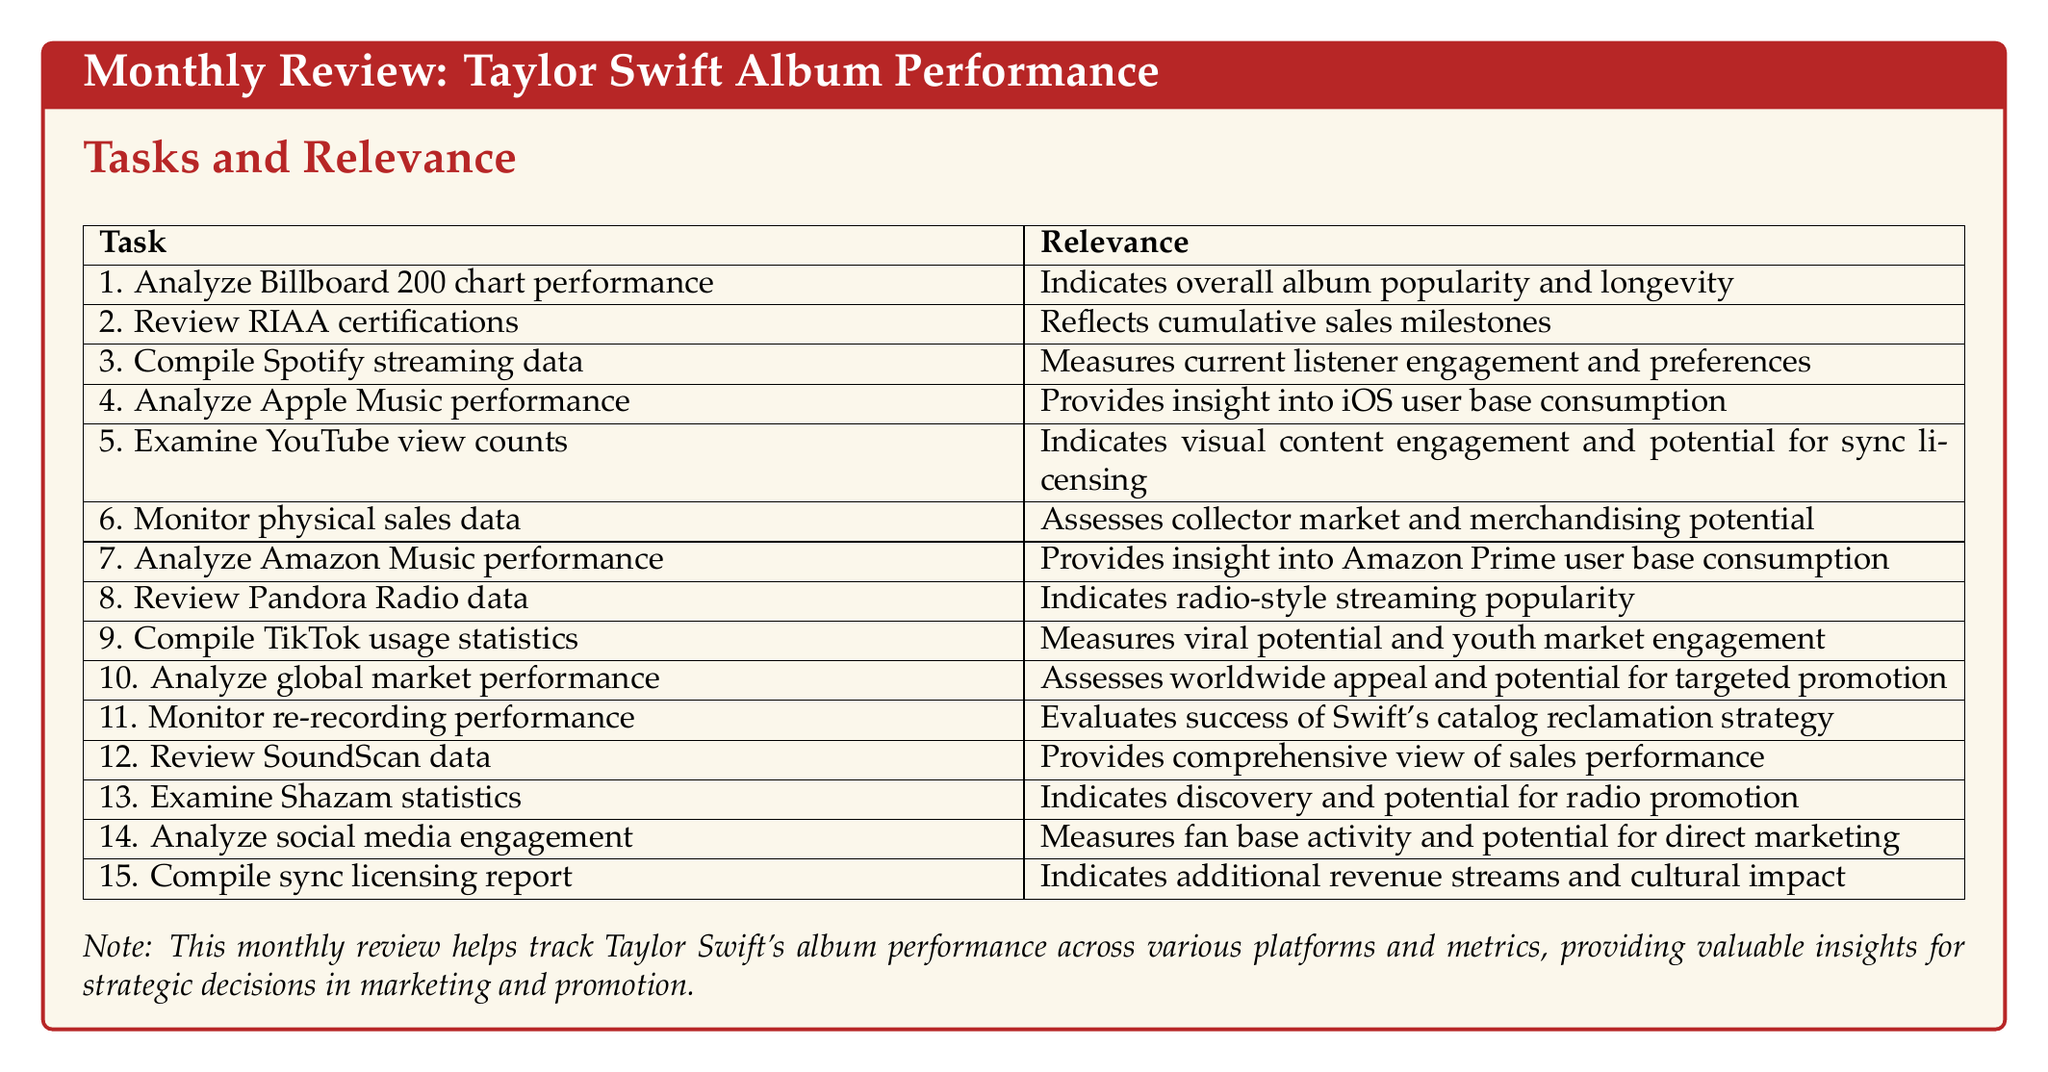What is the title of the document? The title of the document is stated at the beginning and is "Monthly Review: Taylor Swift Album Performance."
Answer: Monthly Review: Taylor Swift Album Performance How many tasks are listed in the document? The document lists a total of 15 tasks under "Tasks and Relevance."
Answer: 15 What does the task "Review RIAA certifications" measure? This task reflects cumulative sales milestones for Taylor Swift's albums.
Answer: Cumulative sales milestones Which streaming platform's performance is analyzed with a focus on iOS users? The task specifically reviews album and song rankings on Apple Music charts, indicating focus on iOS user base consumption.
Answer: Apple Music What key aspect does the "Compile TikTok usage statistics" task evaluate? This task measures viral potential and youth market engagement through the number of videos created using Swift's songs.
Answer: Viral potential and youth market engagement What is the purpose of monitoring re-recording performance? The purpose is to evaluate the success of Swift's catalog reclamation strategy by comparing original and re-recorded versions.
Answer: Success of Swift's catalog reclamation strategy What is the relevance of the task "Examine Shazam statistics"? This task indicates discovery and potential for radio promotion by tracking Shazam searches for Swift's songs.
Answer: Discovery and potential for radio promotion What can the "Compile sync licensing report" inform about? This task tracks the usage of Swift's music in media, indicating additional revenue streams and cultural impact.
Answer: Additional revenue streams and cultural impact 